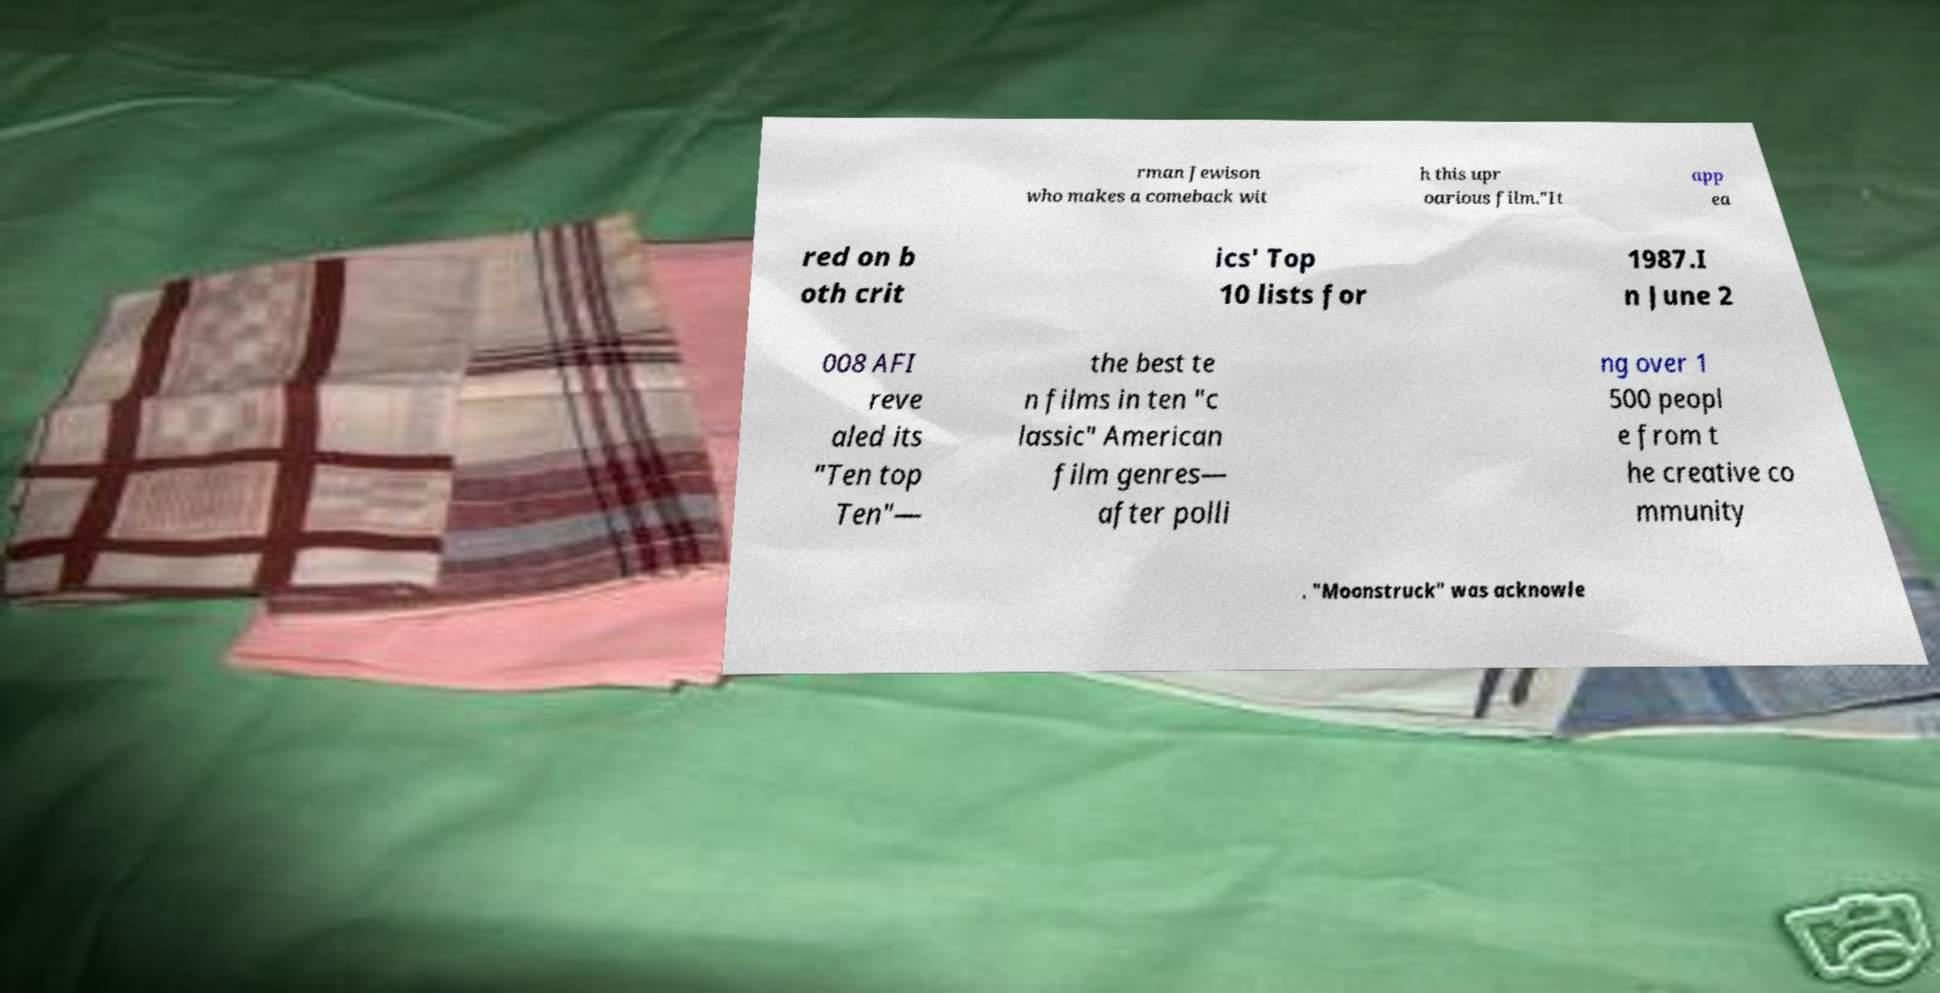Please identify and transcribe the text found in this image. rman Jewison who makes a comeback wit h this upr oarious film."It app ea red on b oth crit ics' Top 10 lists for 1987.I n June 2 008 AFI reve aled its "Ten top Ten"— the best te n films in ten "c lassic" American film genres— after polli ng over 1 500 peopl e from t he creative co mmunity . "Moonstruck" was acknowle 